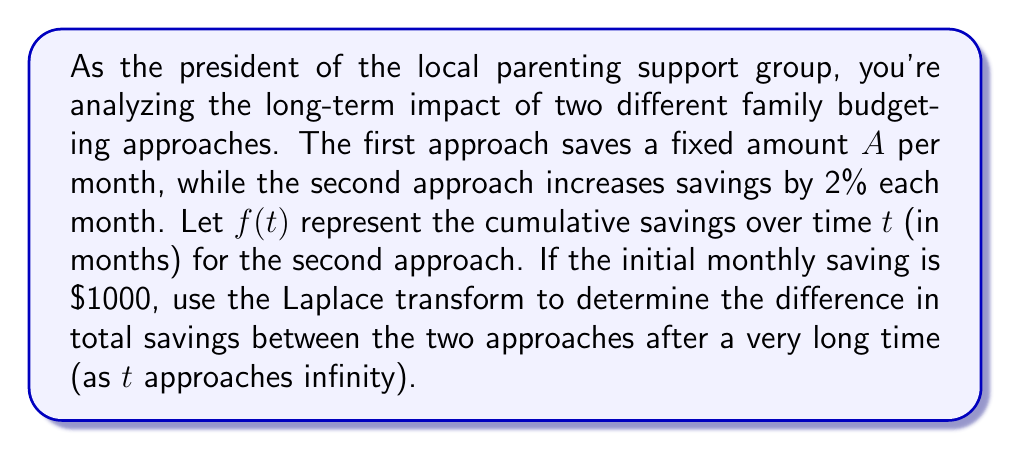Solve this math problem. Let's approach this step-by-step using Laplace transforms:

1) For the first approach (fixed savings), the cumulative savings function is:
   $$F_1(t) = 1000t$$

2) For the second approach (2% monthly increase), we can model the cumulative savings as:
   $$f(t) = 1000 \int_0^t (1.02)^x dx$$

3) To solve this, let's use the Laplace transform. The Laplace transform of $f(t)$ is:
   $$\mathcal{L}\{f(t)\} = F(s) = \int_0^\infty e^{-st} f(t) dt$$

4) For our function:
   $$F(s) = 1000 \int_0^\infty e^{-st} \int_0^t (1.02)^x dx dt$$

5) Changing the order of integration:
   $$F(s) = 1000 \int_0^\infty (1.02)^x \int_x^\infty e^{-st} dt dx$$

6) Solving the inner integral:
   $$F(s) = 1000 \int_0^\infty (1.02)^x \left[-\frac{1}{s}e^{-st}\right]_x^\infty dx$$
   $$F(s) = \frac{1000}{s} \int_0^\infty (1.02)^x e^{-sx} dx$$

7) This integral is of the form $\int_0^\infty a^x e^{-bx} dx = \frac{1}{b-\ln(a)}$ for $b > \ln(a)$:
   $$F(s) = \frac{1000}{s} \cdot \frac{1}{s - \ln(1.02)} = \frac{1000}{s(s - \ln(1.02))}$$

8) To find the long-term behavior, we use the Final Value Theorem:
   $$\lim_{t \to \infty} f(t) = \lim_{s \to 0} sF(s) = \lim_{s \to 0} \frac{1000}{s - \ln(1.02)} = -\frac{1000}{\ln(1.02)}$$

9) For the first approach, as $t$ approaches infinity:
   $$\lim_{t \to \infty} F_1(t) = \lim_{t \to \infty} 1000t = \infty$$

10) The difference between the two approaches as $t$ approaches infinity is:
    $$\text{Difference} = \infty - (-\frac{1000}{\ln(1.02)}) = \infty$$
Answer: The difference in total savings between the two approaches after a very long time (as $t$ approaches infinity) is infinite. The fixed savings approach accumulates infinitely more than the approach with a 2% monthly increase. 